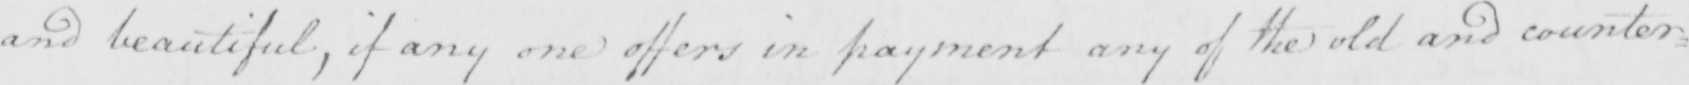Please transcribe the handwritten text in this image. and beautiful , if any one offers in payment any of the old and counter= 